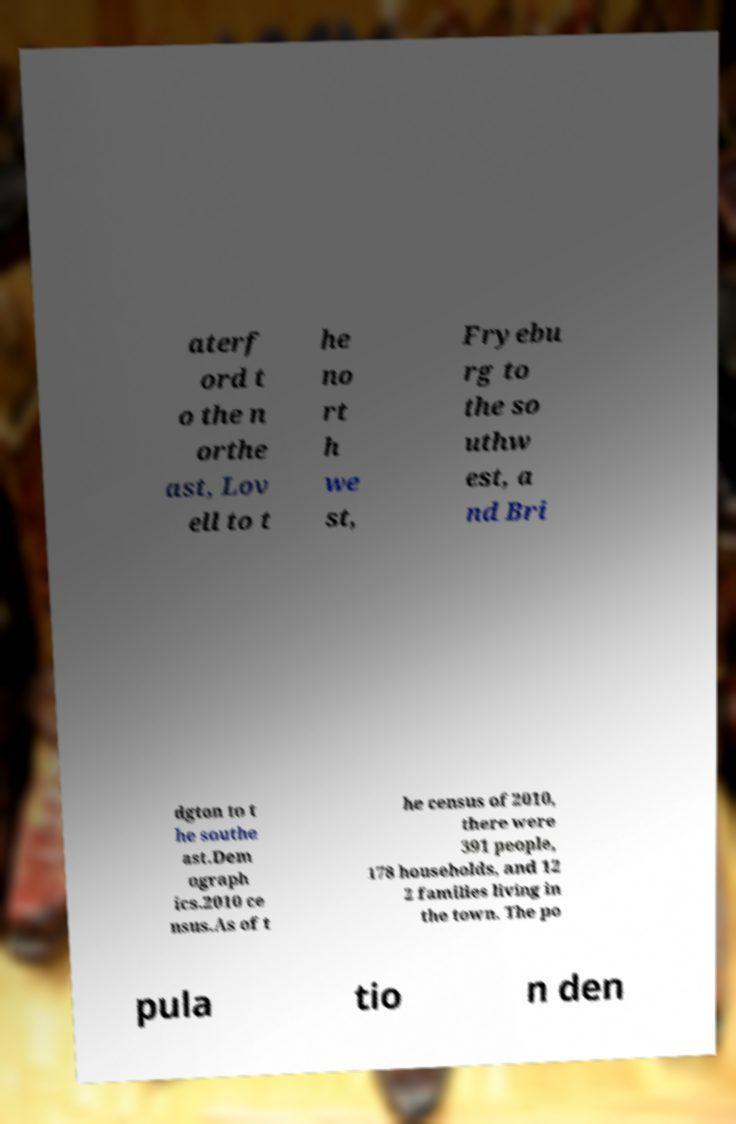Please read and relay the text visible in this image. What does it say? aterf ord t o the n orthe ast, Lov ell to t he no rt h we st, Fryebu rg to the so uthw est, a nd Bri dgton to t he southe ast.Dem ograph ics.2010 ce nsus.As of t he census of 2010, there were 391 people, 178 households, and 12 2 families living in the town. The po pula tio n den 